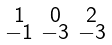<formula> <loc_0><loc_0><loc_500><loc_500>\begin{smallmatrix} 1 & 0 & 2 \\ - 1 & - 3 & - 3 \end{smallmatrix}</formula> 